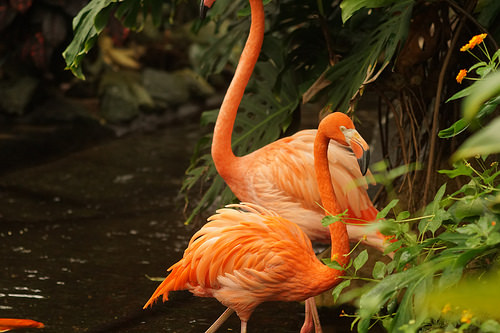<image>
Is the animal to the right of the animal? No. The animal is not to the right of the animal. The horizontal positioning shows a different relationship. 